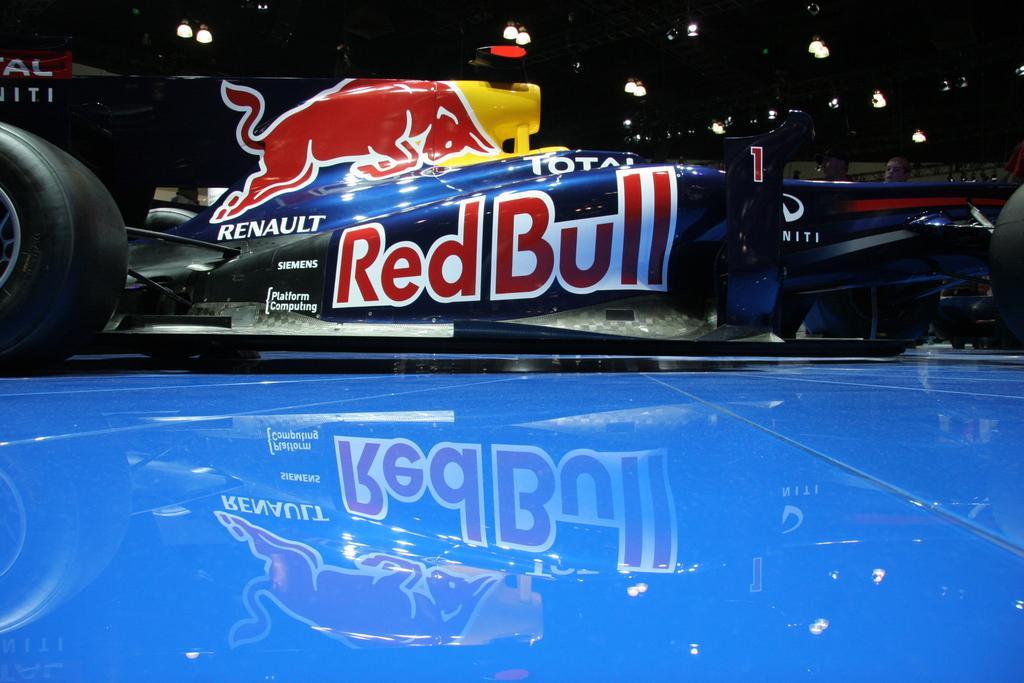Could you give a brief overview of what you see in this image? In this picture there is a go kart. In the foreground there is a blue surface. At the top there are lights to the ceiling. 